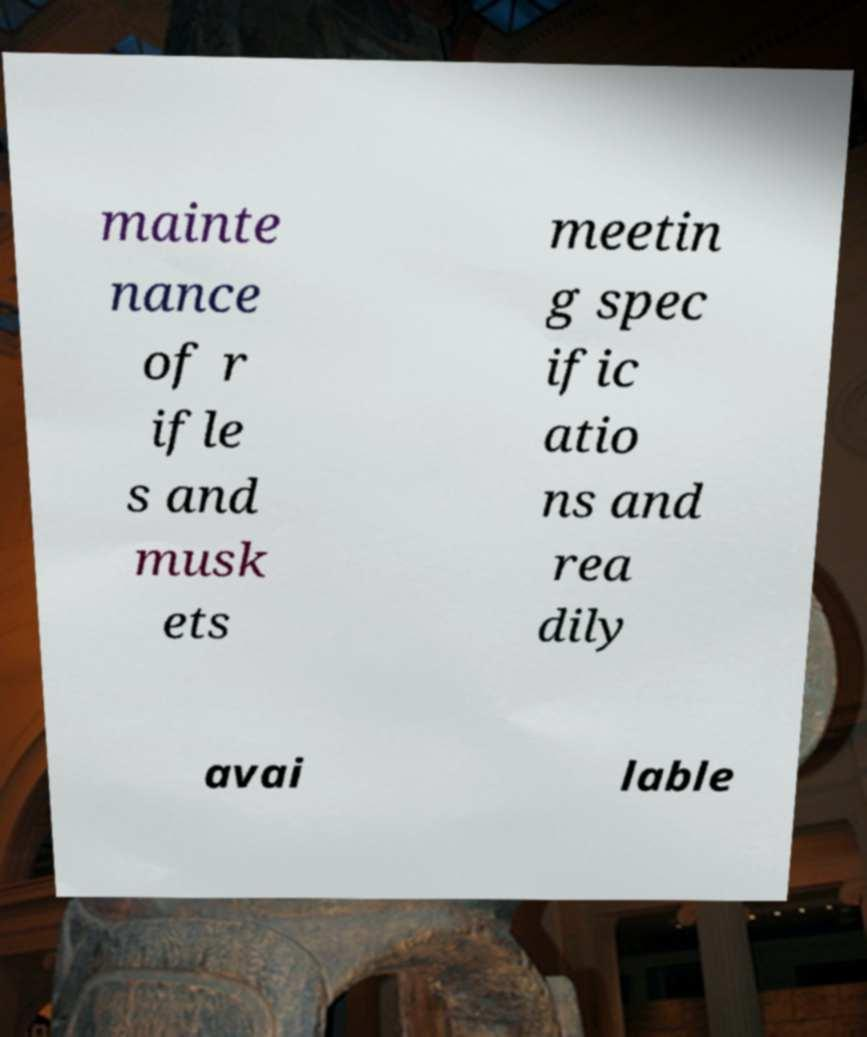Can you read and provide the text displayed in the image?This photo seems to have some interesting text. Can you extract and type it out for me? mainte nance of r ifle s and musk ets meetin g spec ific atio ns and rea dily avai lable 